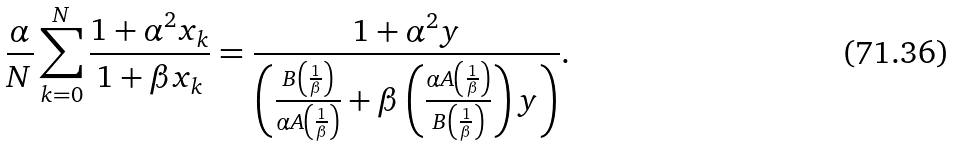Convert formula to latex. <formula><loc_0><loc_0><loc_500><loc_500>\frac { \alpha } { N } \sum _ { k = 0 } ^ { N } \frac { 1 + \alpha ^ { 2 } x _ { k } } { 1 + \beta x _ { k } } = \frac { 1 + \alpha ^ { 2 } y } { \left ( \frac { B \left ( \frac { 1 } { \beta } \right ) } { \alpha A \left ( \frac { 1 } { \beta } \right ) } + \beta \left ( \frac { \alpha A \left ( \frac { 1 } { \beta } \right ) } { B \left ( \frac { 1 } { \beta } \right ) } \right ) y \right ) } .</formula> 